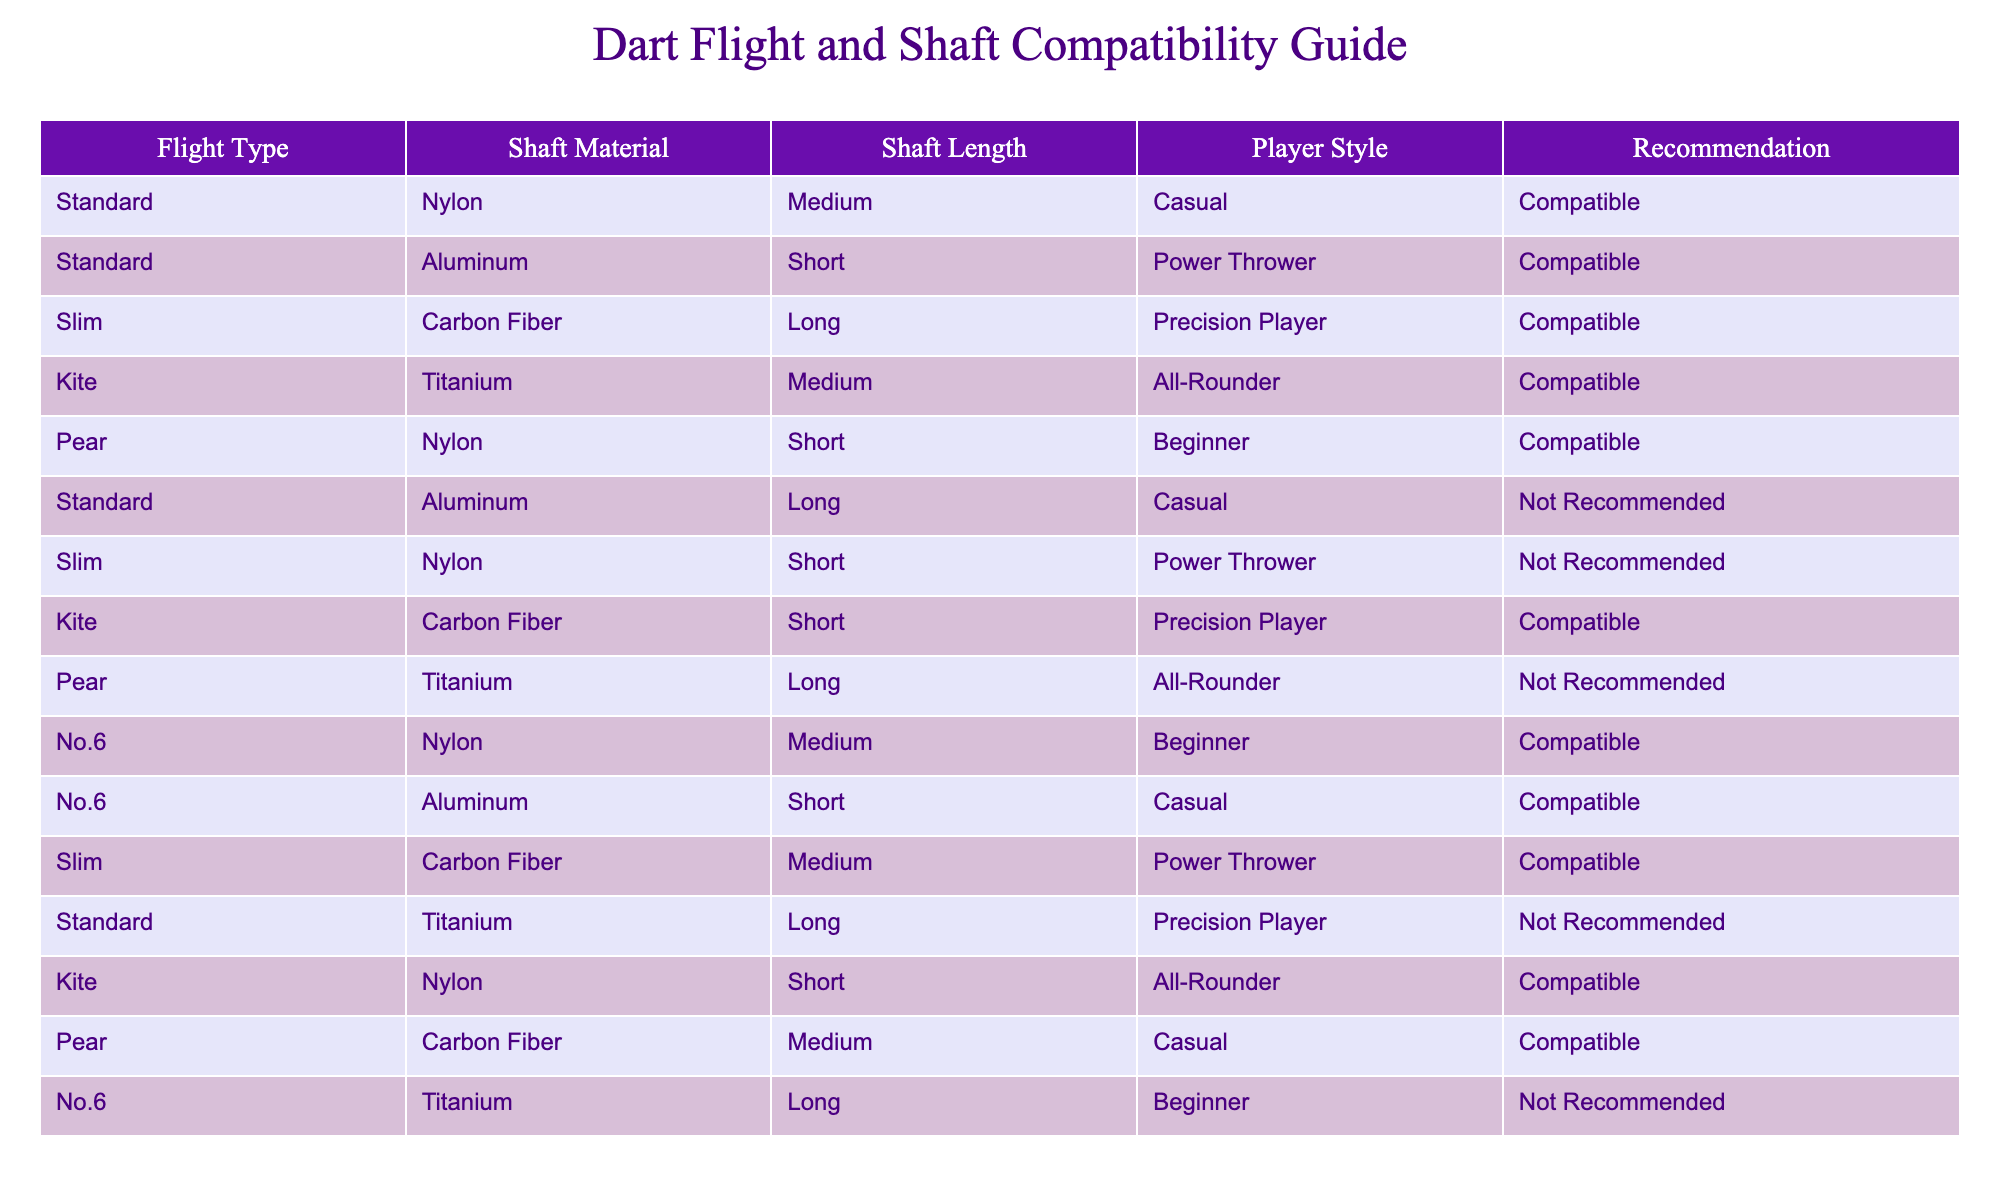What is the recommendation for a Standard flight with a Nylon shaft of medium length for a casual player? The table indicates that for a Standard flight with a Nylon shaft of medium length, the recommendation is "Compatible".
Answer: Compatible Is a Slim flight with a Carbon Fiber shaft and medium length suitable for a Power Thrower? According to the table, a Slim flight with a Carbon Fiber shaft of medium length is "Compatible" for a Power Thrower.
Answer: Compatible How many flight types are "Not Recommended"? In the table, there are three types listed as "Not Recommended" - Standard with Aluminum (Long, Casual), Slim with Nylon (Short, Power Thrower), and Standard with Titanium (Long, Precision Player). Thus, there are three flight types in total that are not recommended.
Answer: 3 What is the total number of compatible options for flights made with Nylon shafts? The table lists six compatible options for flights with Nylon shafts: Standard (Medium, Casual), Pear (Short, Beginner), No.6 (Medium, Beginner), No.6 (Short, Casual), Kite (Short, All-Rounder), and Pear (Medium, Casual). The total is six compatible options.
Answer: 6 Can you confirm if a Pear flight with a Titanium shaft and long length is suitable for an All-Rounder? The table indicates that a Pear flight with a Titanium shaft of long length is "Not Recommended" for an All-Rounder. Therefore, this statement is false.
Answer: No What percentage of the total entries is compatible for Precision Players? There are three entries for Precision Players in the table: Slim with Carbon Fiber (Long), Kite with Titanium (Medium), and Standard with Titanium (Long). Out of a total of 12 entries, two entries (Slim with Carbon Fiber, Kite with Carbon Fiber) are indicated as compatible. Therefore, the percentage is (2/12)*100 = 16.67%.
Answer: 16.67% Is it true that all Standard flights are suitable for casual players? The table shows that of the three Standard flights, two are compatible (Standard with Nylon, Medium) and one is not (Standard with Aluminum, Long). Therefore, it's not true that all Standard flights are suitable for casual players.
Answer: No What would be the average shaft length for the compatible options featuring Carbon Fiber shafts? There are three compatible options with Carbon Fiber shafts: Slim (Medium), Kite (Short), and Pear (Medium). The corresponding lengths are Medium (approximately 12.5 cm), Short (approximately 10 cm), and Medium (12.5 cm). To find the average, we calculate (12.5 + 10 + 12.5) / 3 = 11.67 cm.
Answer: 11.67 cm 